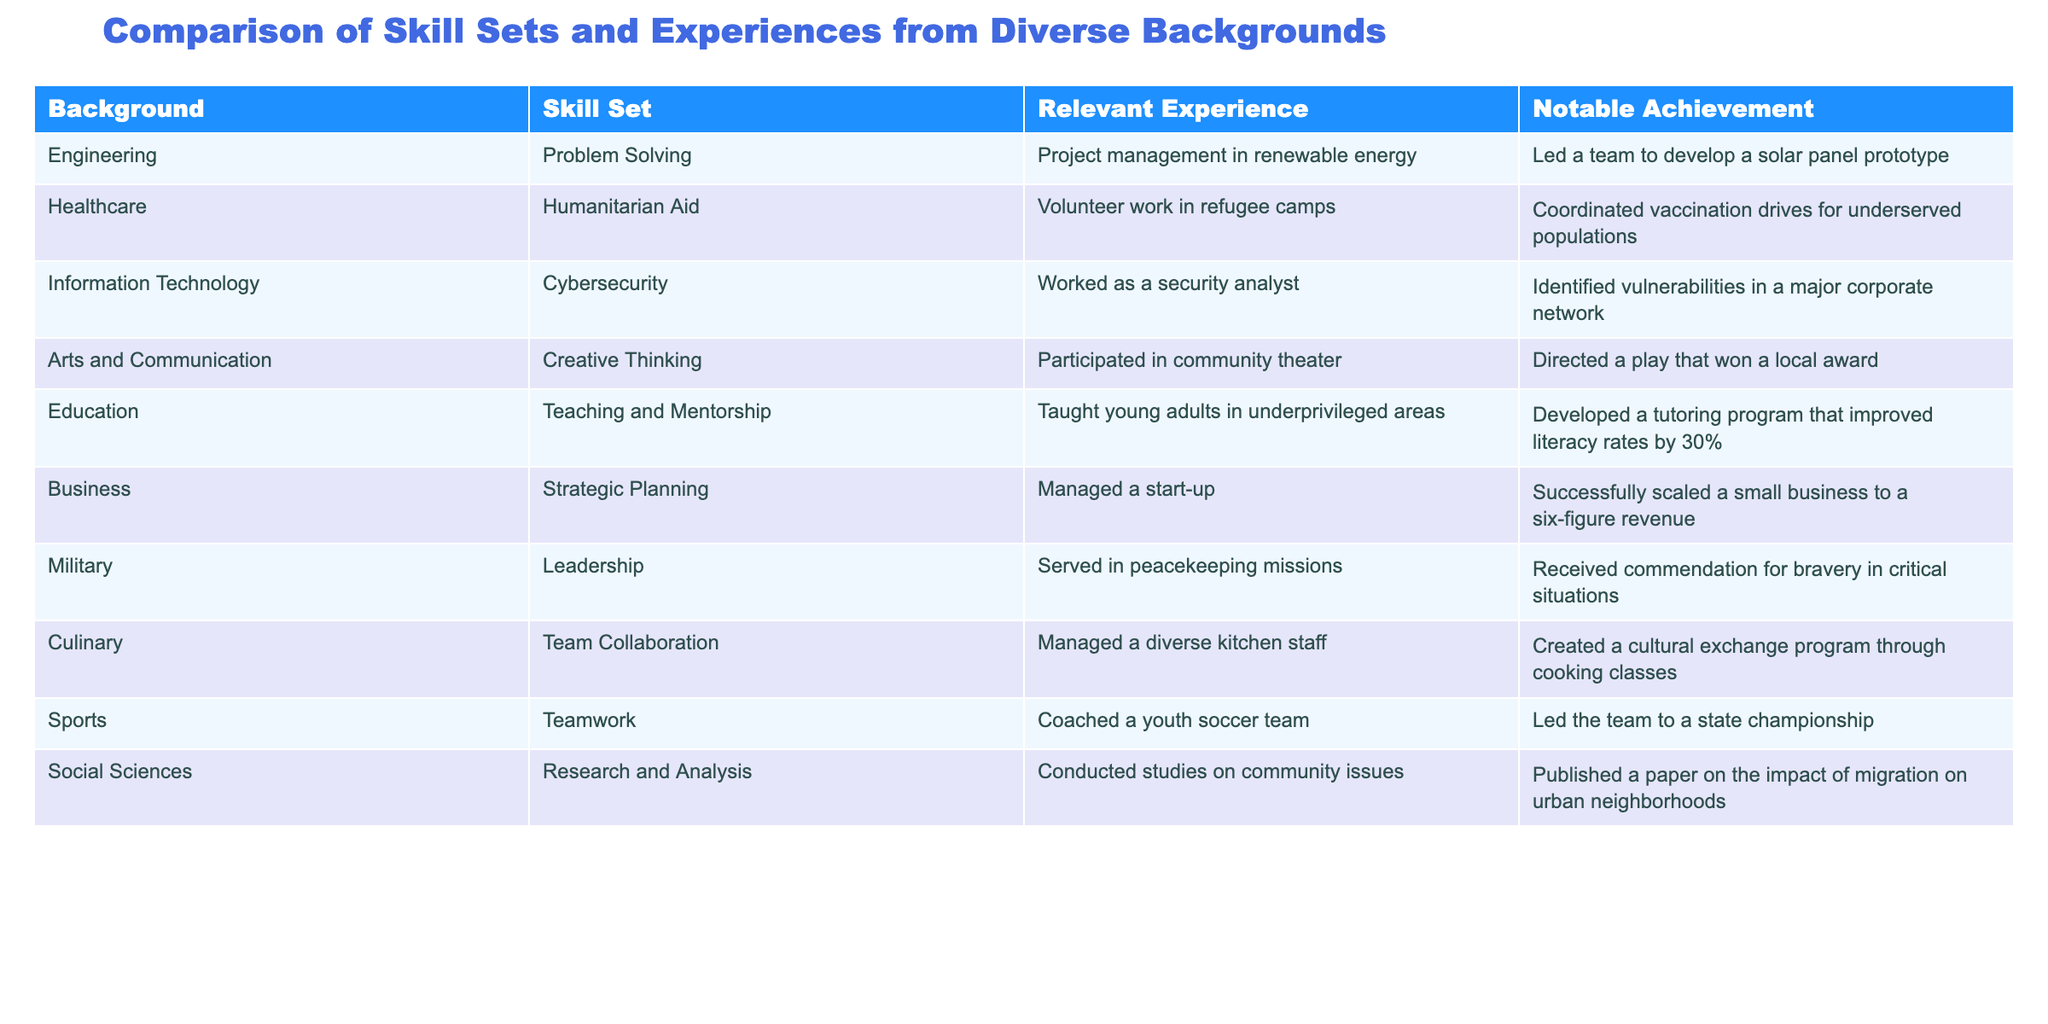What skill set is associated with the Culinary background? The table indicates that the skill set associated with the Culinary background is Team Collaboration.
Answer: Team Collaboration Which notable achievement did the recruit with a Healthcare background accomplish? According to the table, the notable achievement for the Healthcare background is coordinating vaccination drives for underserved populations.
Answer: Coordinated vaccination drives for underserved populations How many recruits listed have expertise in problem-solving skills? There are two entries—Engineering and Military—that indicate the skill set of Problem Solving.
Answer: 2 Is there any background associated with Teaching and Mentorship? Yes, the Education background is linked to Teaching and Mentorship.
Answer: Yes Which backgrounds have the relevant experience of managing teams? The backgrounds that include managing teams in their relevant experience are Business, Military, and Culinary.
Answer: Business, Military, Culinary What is the notable achievement of the recruit from the Social Sciences background? The table states that the notable achievement for Social Sciences is publishing a paper on the impact of migration on urban neighborhoods.
Answer: Published a paper on the impact of migration on urban neighborhoods Do any recruits possess skills in Creative Thinking? Yes, the Arts and Communication background is associated with the skill of Creative Thinking.
Answer: Yes Which background has the highest literacy rate improvement noted in their achievement? The Education background is noted for developing a tutoring program that improved literacy rates by 30%, making it the highest recognized improvement.
Answer: Education background (30% improvement) How many backgrounds mention coordination or management as a relevant experience? The backgrounds that mention coordination or management in relevant experience are Healthcare, Business, Military, and Culinary. This results in a total of four backgrounds.
Answer: 4 